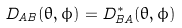<formula> <loc_0><loc_0><loc_500><loc_500>D _ { A B } ( \theta , \phi ) = D ^ { \ast } _ { B A } ( \theta , \phi )</formula> 